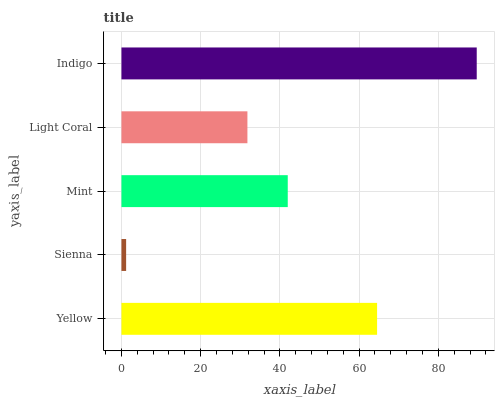Is Sienna the minimum?
Answer yes or no. Yes. Is Indigo the maximum?
Answer yes or no. Yes. Is Mint the minimum?
Answer yes or no. No. Is Mint the maximum?
Answer yes or no. No. Is Mint greater than Sienna?
Answer yes or no. Yes. Is Sienna less than Mint?
Answer yes or no. Yes. Is Sienna greater than Mint?
Answer yes or no. No. Is Mint less than Sienna?
Answer yes or no. No. Is Mint the high median?
Answer yes or no. Yes. Is Mint the low median?
Answer yes or no. Yes. Is Indigo the high median?
Answer yes or no. No. Is Light Coral the low median?
Answer yes or no. No. 